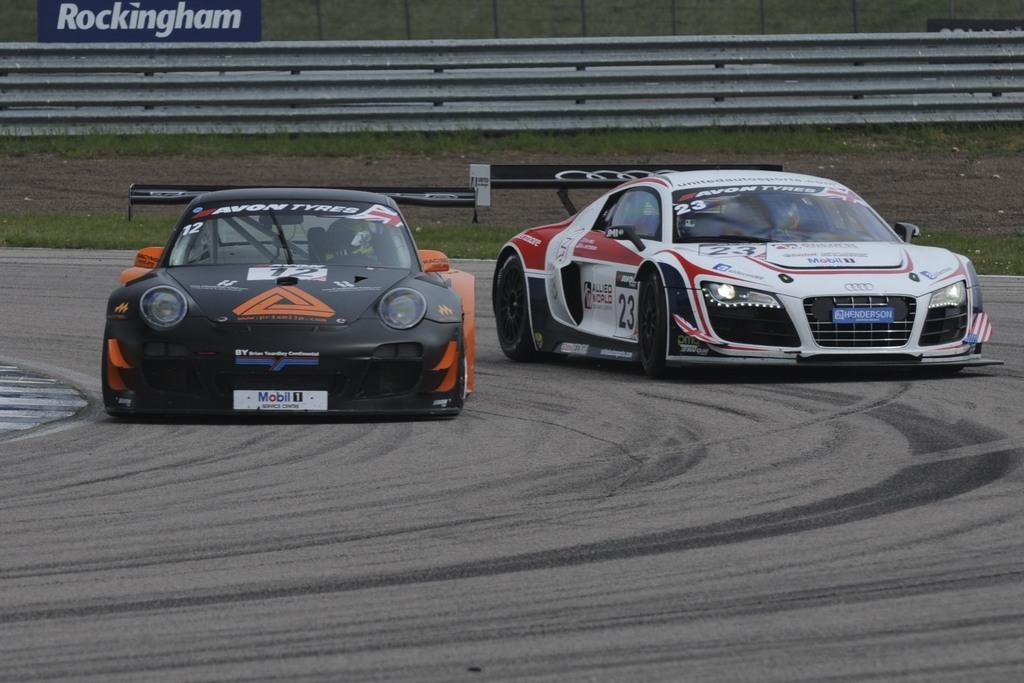How many vehicles can be seen in the image? There are two vehicles in the image. What are the colors of the vehicles? The vehicles are in different colors. What type of barrier is visible in the image? There is fencing visible in the image. What is the color of the board in the image? There is a blue board in the image. What type of vegetation is visible in the image? There is grass visible in the image. What type of zinc object is present in the image? There is no zinc object present in the image. How many balloons are tied to the vehicles in the image? There are no balloons visible in the image. 